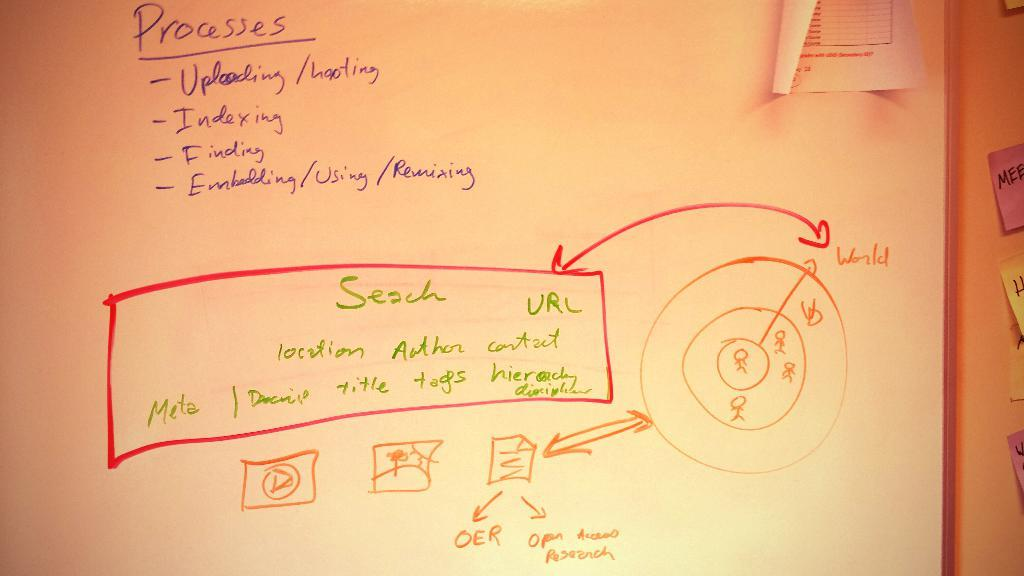<image>
Describe the image concisely. A whiteboard displaying the processes for uploading files to a server. 